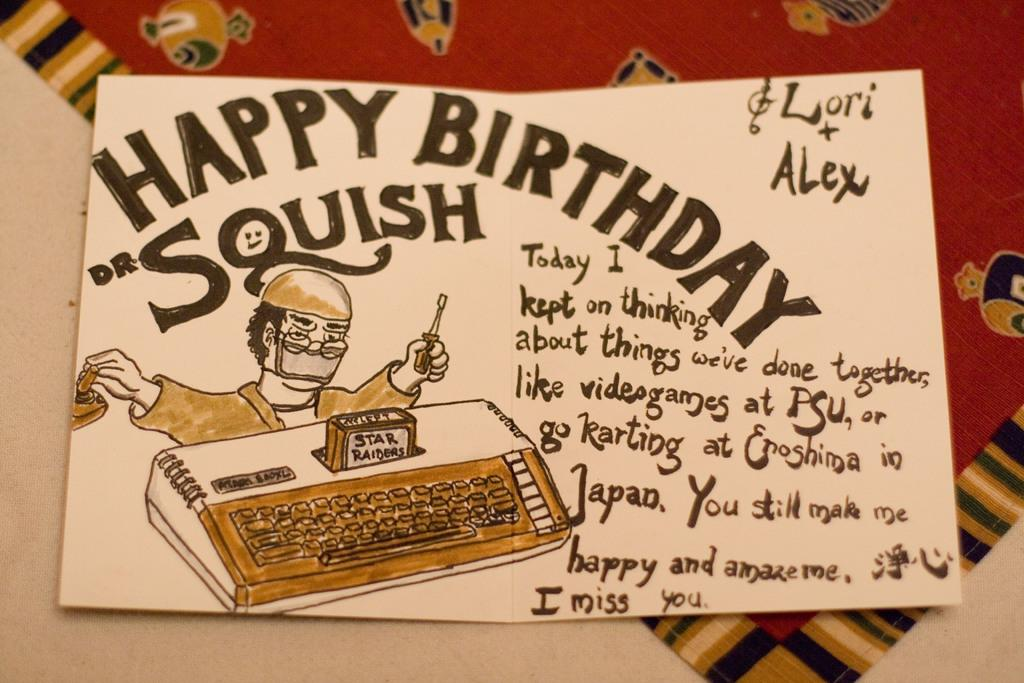<image>
Provide a brief description of the given image. A card that says happy birthday squis by lori and alex. 